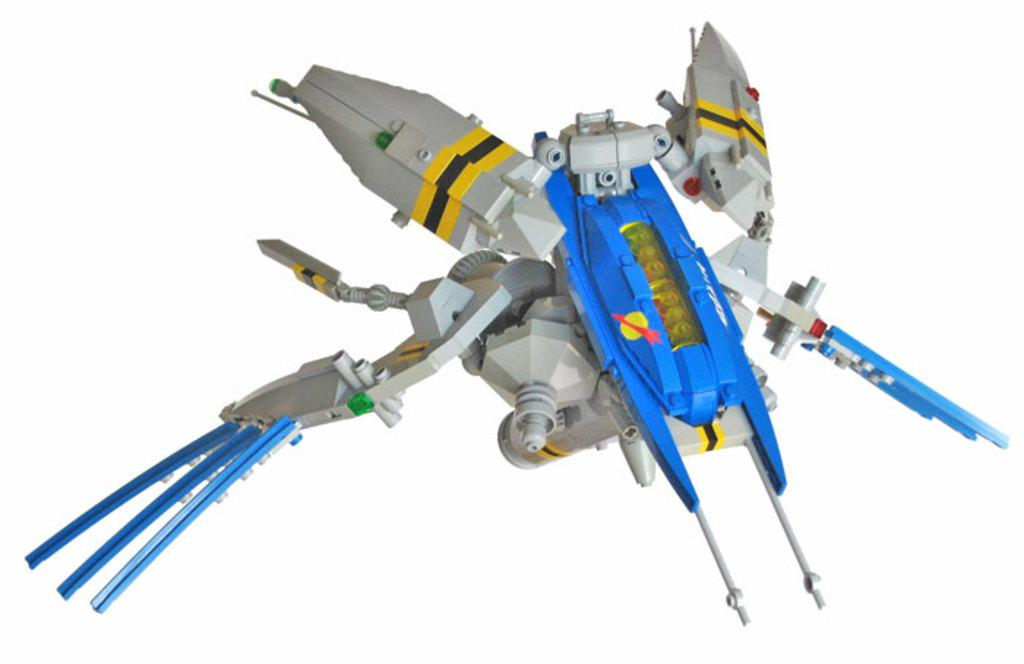What is the main object in the image? There is a toy in the image. Can you describe the colors of the toy? The toy has white, blue, yellow, and black colors. What is the color of the background in the image? The background of the image is white. How many snails can be seen crawling on the toy in the image? There are no snails present in the image; it only features a toy with various colors. 